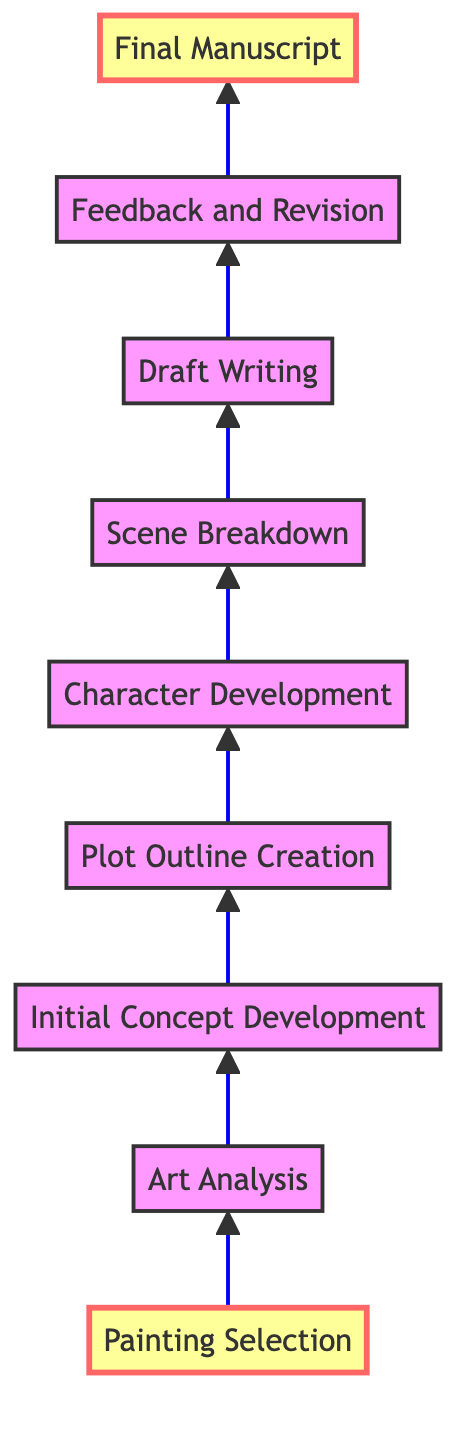What is the first step in the process? The diagram indicates that "Painting Selection" is the first node at the bottom of the flow chart, showing it as the initial step in the book plot development inspired by a painting.
Answer: Painting Selection How many nodes are in the diagram? Counting all the steps from "Painting Selection" to "Final Manuscript," there are a total of nine nodes listed in the flow chart.
Answer: Nine What comes before "Character Development"? Referring to the flow of the diagram, "Plot Outline Creation" is the step that directly precedes "Character Development."
Answer: Plot Outline Creation What is the final stage of the book development process? The last node at the top of the flow chart is labeled "Final Manuscript," which indicates the conclusion of the development process.
Answer: Final Manuscript Which step involves reviewing the draft with the artist? The node labeled "Feedback and Revision" signifies the step where the draft is reviewed and feedback is integrated with the artist's insights.
Answer: Feedback and Revision What is the relationship between "Initial Concept Development" and "Plot Outline Creation"? In the diagram, "Initial Concept Development" leads directly to "Plot Outline Creation," indicating that the ideas generated in the initial concept phase are used to create the plot outline.
Answer: Leads to Which step is focused on breaking down the plot into scenes? The step named "Scene Breakdown" is specifically designated for dividing the plot outline into scenes or chapters for detailed development.
Answer: Scene Breakdown What is the purpose of "Art Analysis" in this process? "Art Analysis" serves to examine the painting's details, themes, and mood to extract ideas for the initial plot, linking the painting to the storytelling process.
Answer: Extract initial plot ideas Why is "Draft Writing" located lower in the diagram compared to "Final Manuscript"? In a bottom-to-top flow chart, "Draft Writing" appears before "Final Manuscript" because draft writing occurs earlier in the process, with revisions and finalization happening afterward.
Answer: Earlier in the process 